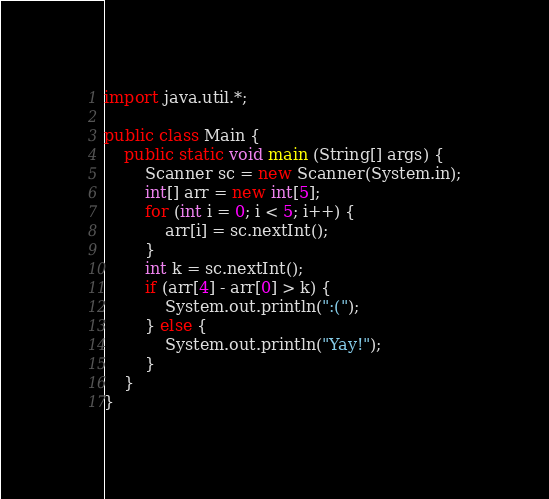<code> <loc_0><loc_0><loc_500><loc_500><_Java_>import java.util.*;

public class Main {
	public static void main (String[] args) {
		Scanner sc = new Scanner(System.in);
		int[] arr = new int[5];
		for (int i = 0; i < 5; i++) {
			arr[i] = sc.nextInt();
		}
		int k = sc.nextInt();
		if (arr[4] - arr[0] > k) {
			System.out.println(":(");
		} else {
			System.out.println("Yay!");
		}
	}
}
</code> 